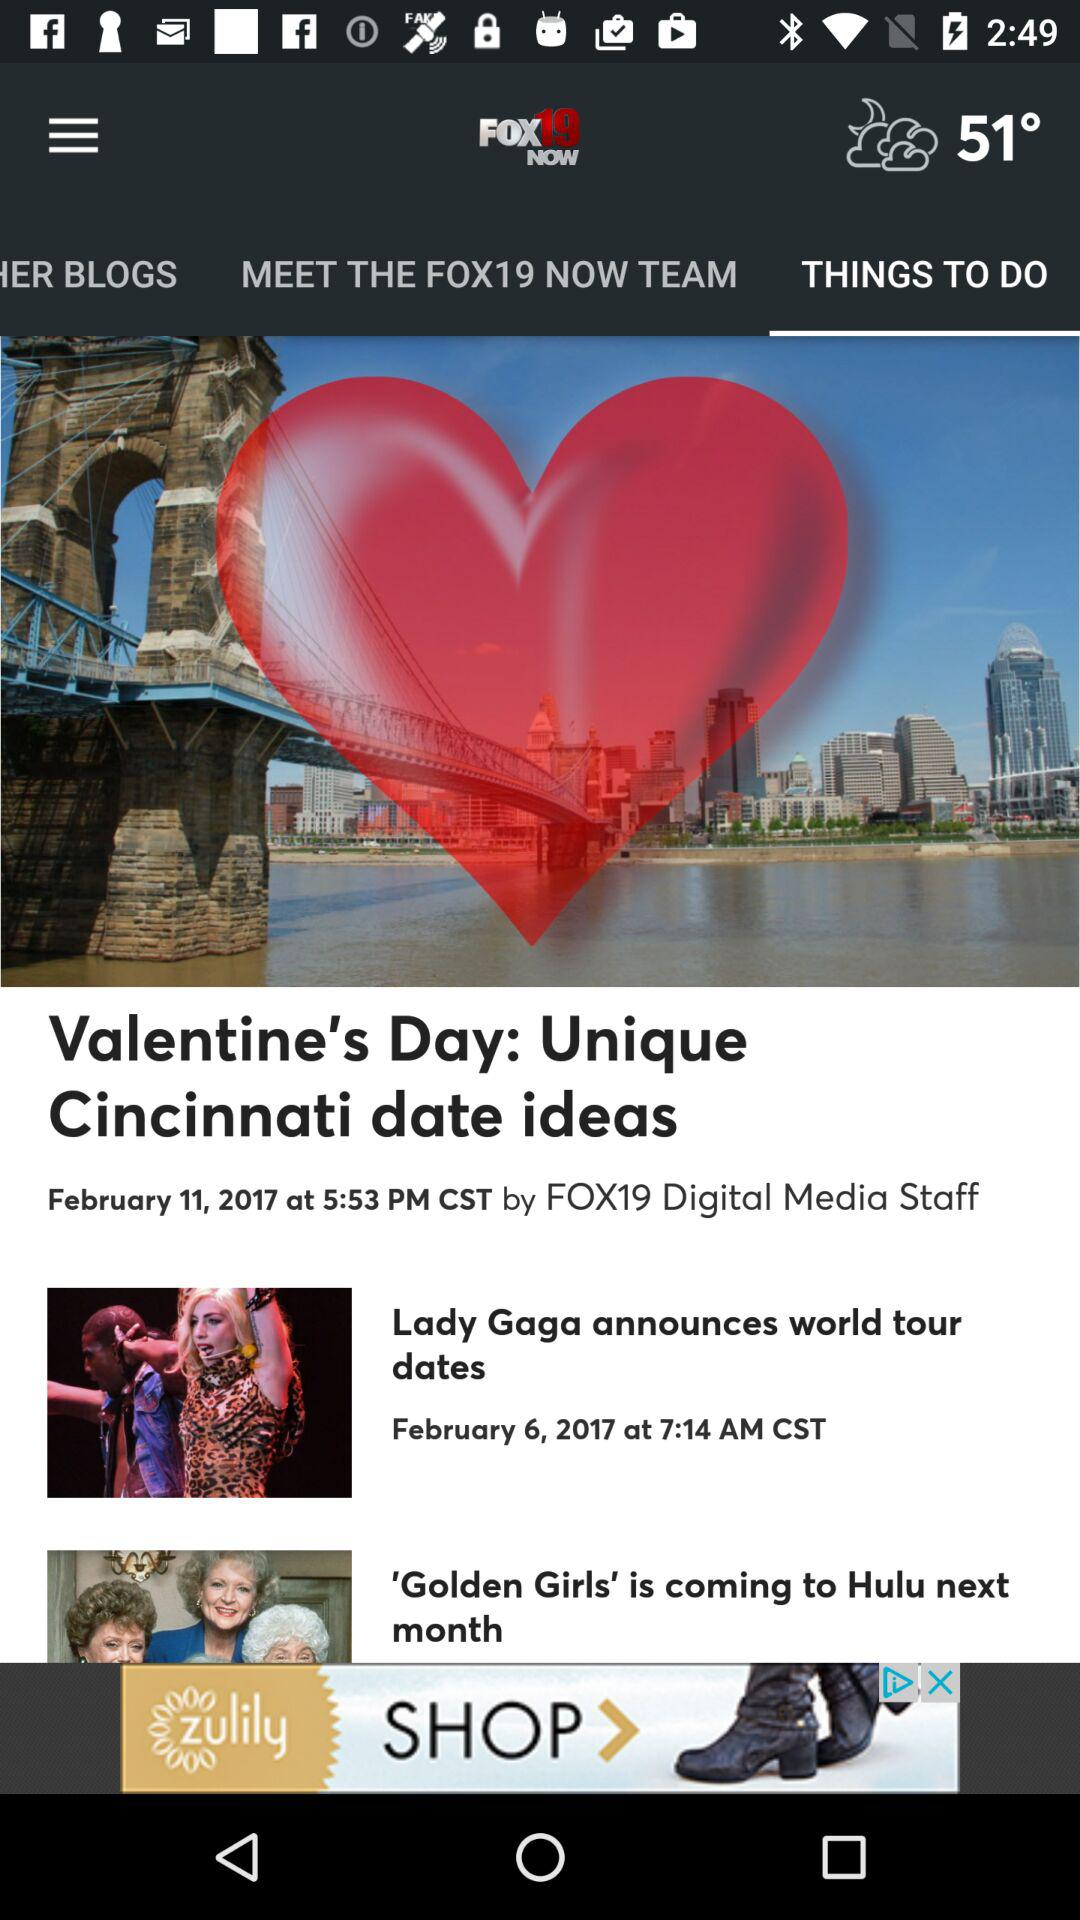On which date was the post "Lady Gaga announces world tour dates" posted? The post was posted on February 6, 2017. 